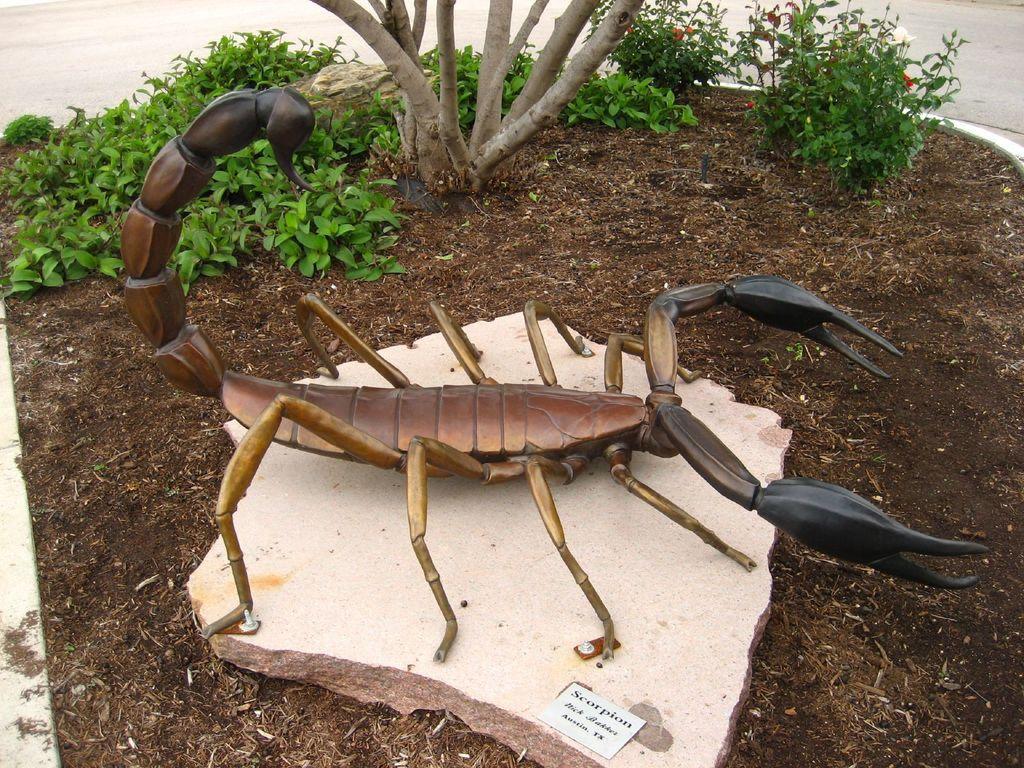Can you describe this image briefly? In this image there is a crab statue on the stone. In the background there are small plants which are planted in the soil. 